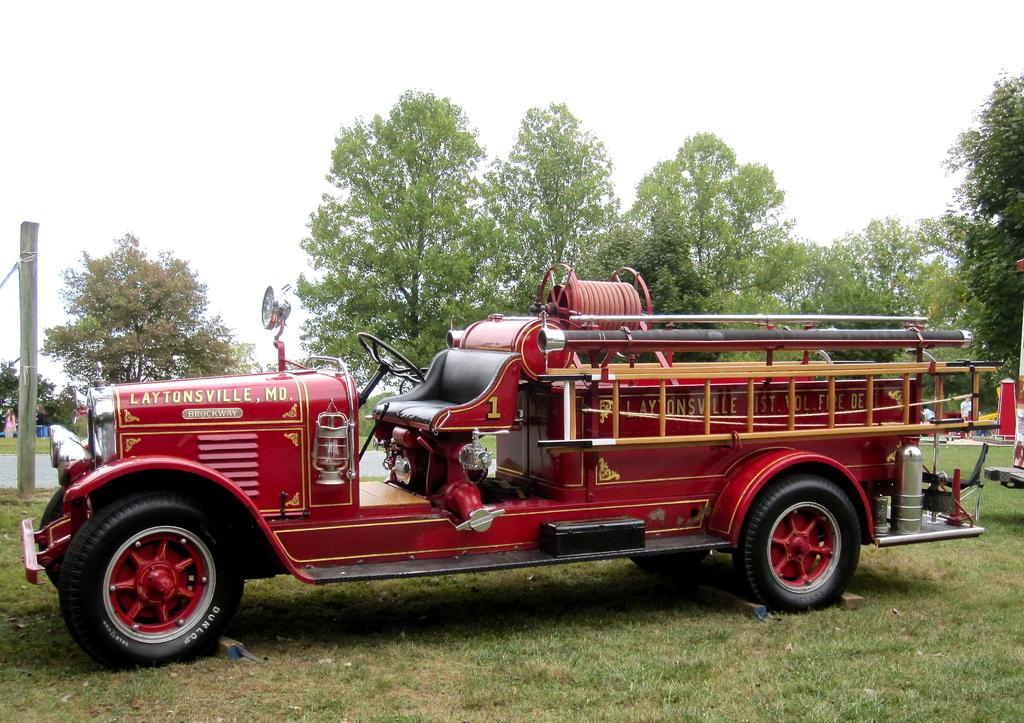What is the main subject of the image? The main subject of the image is a fire engine. Where is the fire engine located in the image? The fire engine is on the ground in the image. What can be seen behind the fire engine? There are trees behind the fire engine. What is the pole in the image used for? The pole in the image is likely used for firefighters to slide down when responding to emergencies. What is visible at the top of the image? The sky is visible at the top of the image. What type of soda is being served at the fire station in the image? There is no soda or fire station present in the image; it only features a fire engine on the ground. What is the title of the book that the firefighter is reading in the image? There is no book or firefighter reading in the image; it only features a fire engine on the ground. 